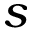<formula> <loc_0><loc_0><loc_500><loc_500>s</formula> 